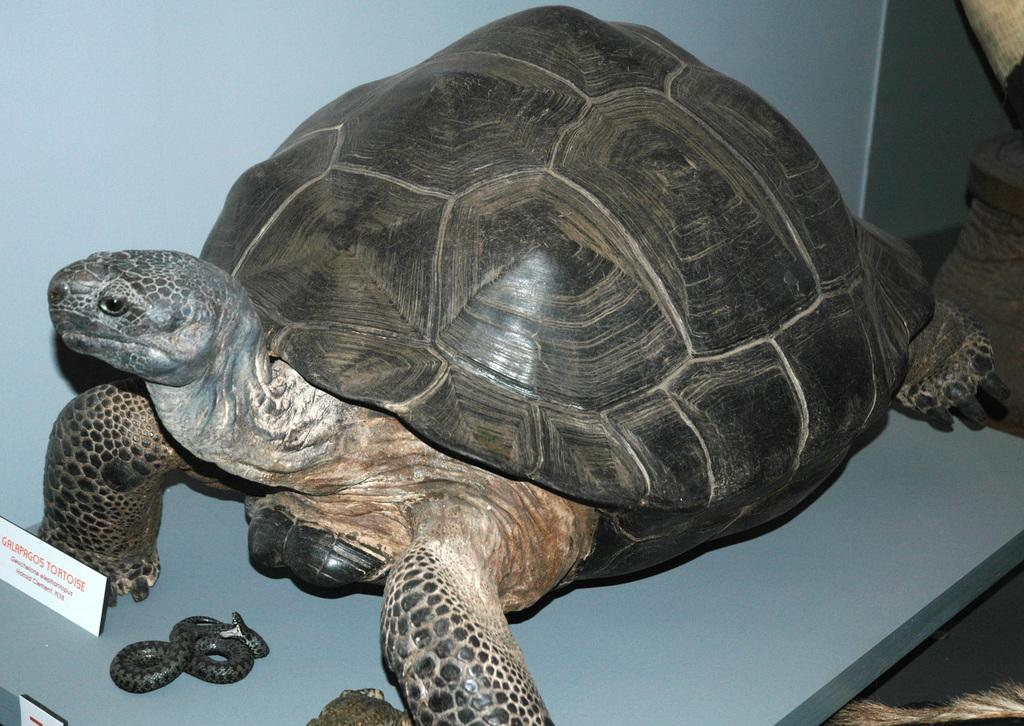What animal is present in the picture? There is a tortoise in the picture. What is positioned in front of the tortoise? There is an object in front of the tortoise. Where can text or writing be found in the image? Text or writing can be found in the left corner of the image. What other objects are visible in the image? There are other objects in the right corner of the image. What type of skirt is the tortoise wearing in the image? The tortoise is not wearing a skirt, as it is an animal and does not wear clothing. 